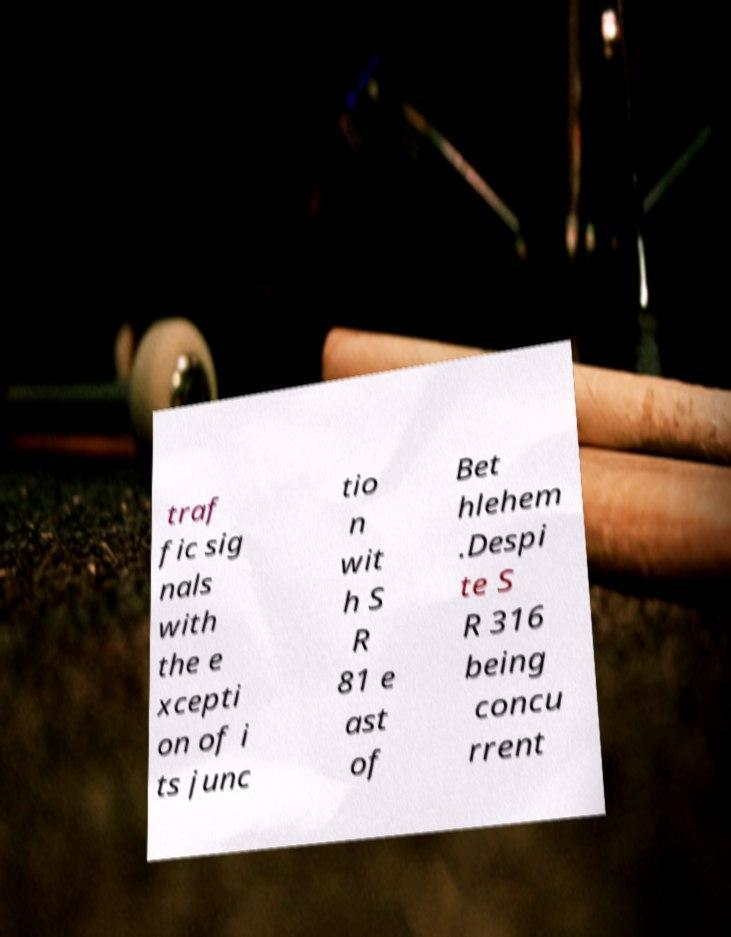Please read and relay the text visible in this image. What does it say? traf fic sig nals with the e xcepti on of i ts junc tio n wit h S R 81 e ast of Bet hlehem .Despi te S R 316 being concu rrent 